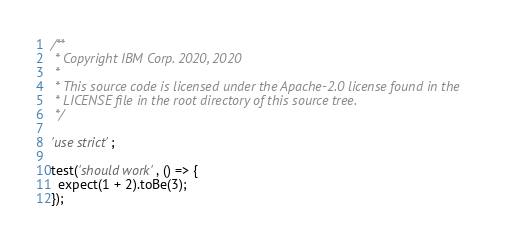<code> <loc_0><loc_0><loc_500><loc_500><_JavaScript_>/**
 * Copyright IBM Corp. 2020, 2020
 *
 * This source code is licensed under the Apache-2.0 license found in the
 * LICENSE file in the root directory of this source tree.
 */

'use strict';

test('should work', () => {
  expect(1 + 2).toBe(3);
});
</code> 